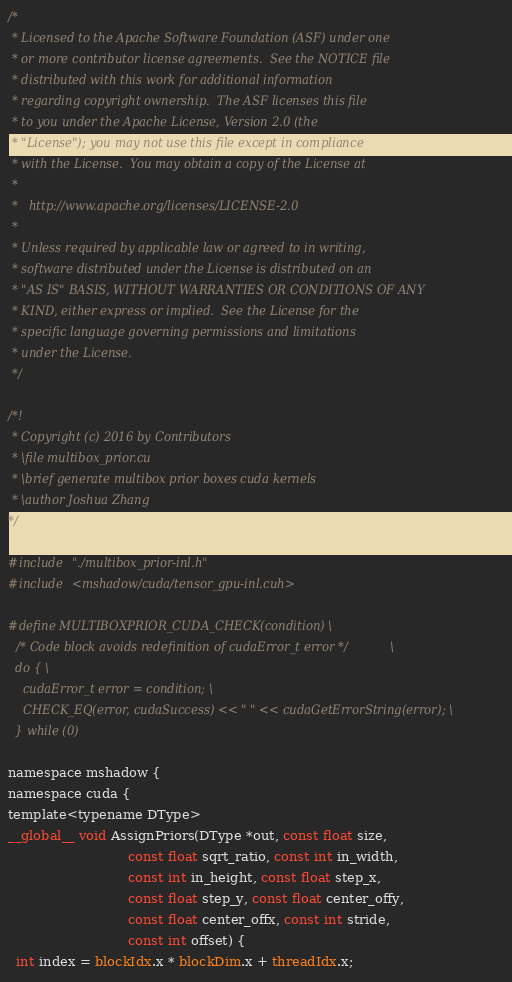Convert code to text. <code><loc_0><loc_0><loc_500><loc_500><_Cuda_>/*
 * Licensed to the Apache Software Foundation (ASF) under one
 * or more contributor license agreements.  See the NOTICE file
 * distributed with this work for additional information
 * regarding copyright ownership.  The ASF licenses this file
 * to you under the Apache License, Version 2.0 (the
 * "License"); you may not use this file except in compliance
 * with the License.  You may obtain a copy of the License at
 *
 *   http://www.apache.org/licenses/LICENSE-2.0
 *
 * Unless required by applicable law or agreed to in writing,
 * software distributed under the License is distributed on an
 * "AS IS" BASIS, WITHOUT WARRANTIES OR CONDITIONS OF ANY
 * KIND, either express or implied.  See the License for the
 * specific language governing permissions and limitations
 * under the License.
 */

/*!
 * Copyright (c) 2016 by Contributors
 * \file multibox_prior.cu
 * \brief generate multibox prior boxes cuda kernels
 * \author Joshua Zhang
*/

#include "./multibox_prior-inl.h"
#include <mshadow/cuda/tensor_gpu-inl.cuh>

#define MULTIBOXPRIOR_CUDA_CHECK(condition) \
  /* Code block avoids redefinition of cudaError_t error */ \
  do { \
    cudaError_t error = condition; \
    CHECK_EQ(error, cudaSuccess) << " " << cudaGetErrorString(error); \
  } while (0)

namespace mshadow {
namespace cuda {
template<typename DType>
__global__ void AssignPriors(DType *out, const float size,
                             const float sqrt_ratio, const int in_width,
                             const int in_height, const float step_x,
                             const float step_y, const float center_offy,
                             const float center_offx, const int stride,
                             const int offset) {
  int index = blockIdx.x * blockDim.x + threadIdx.x;</code> 